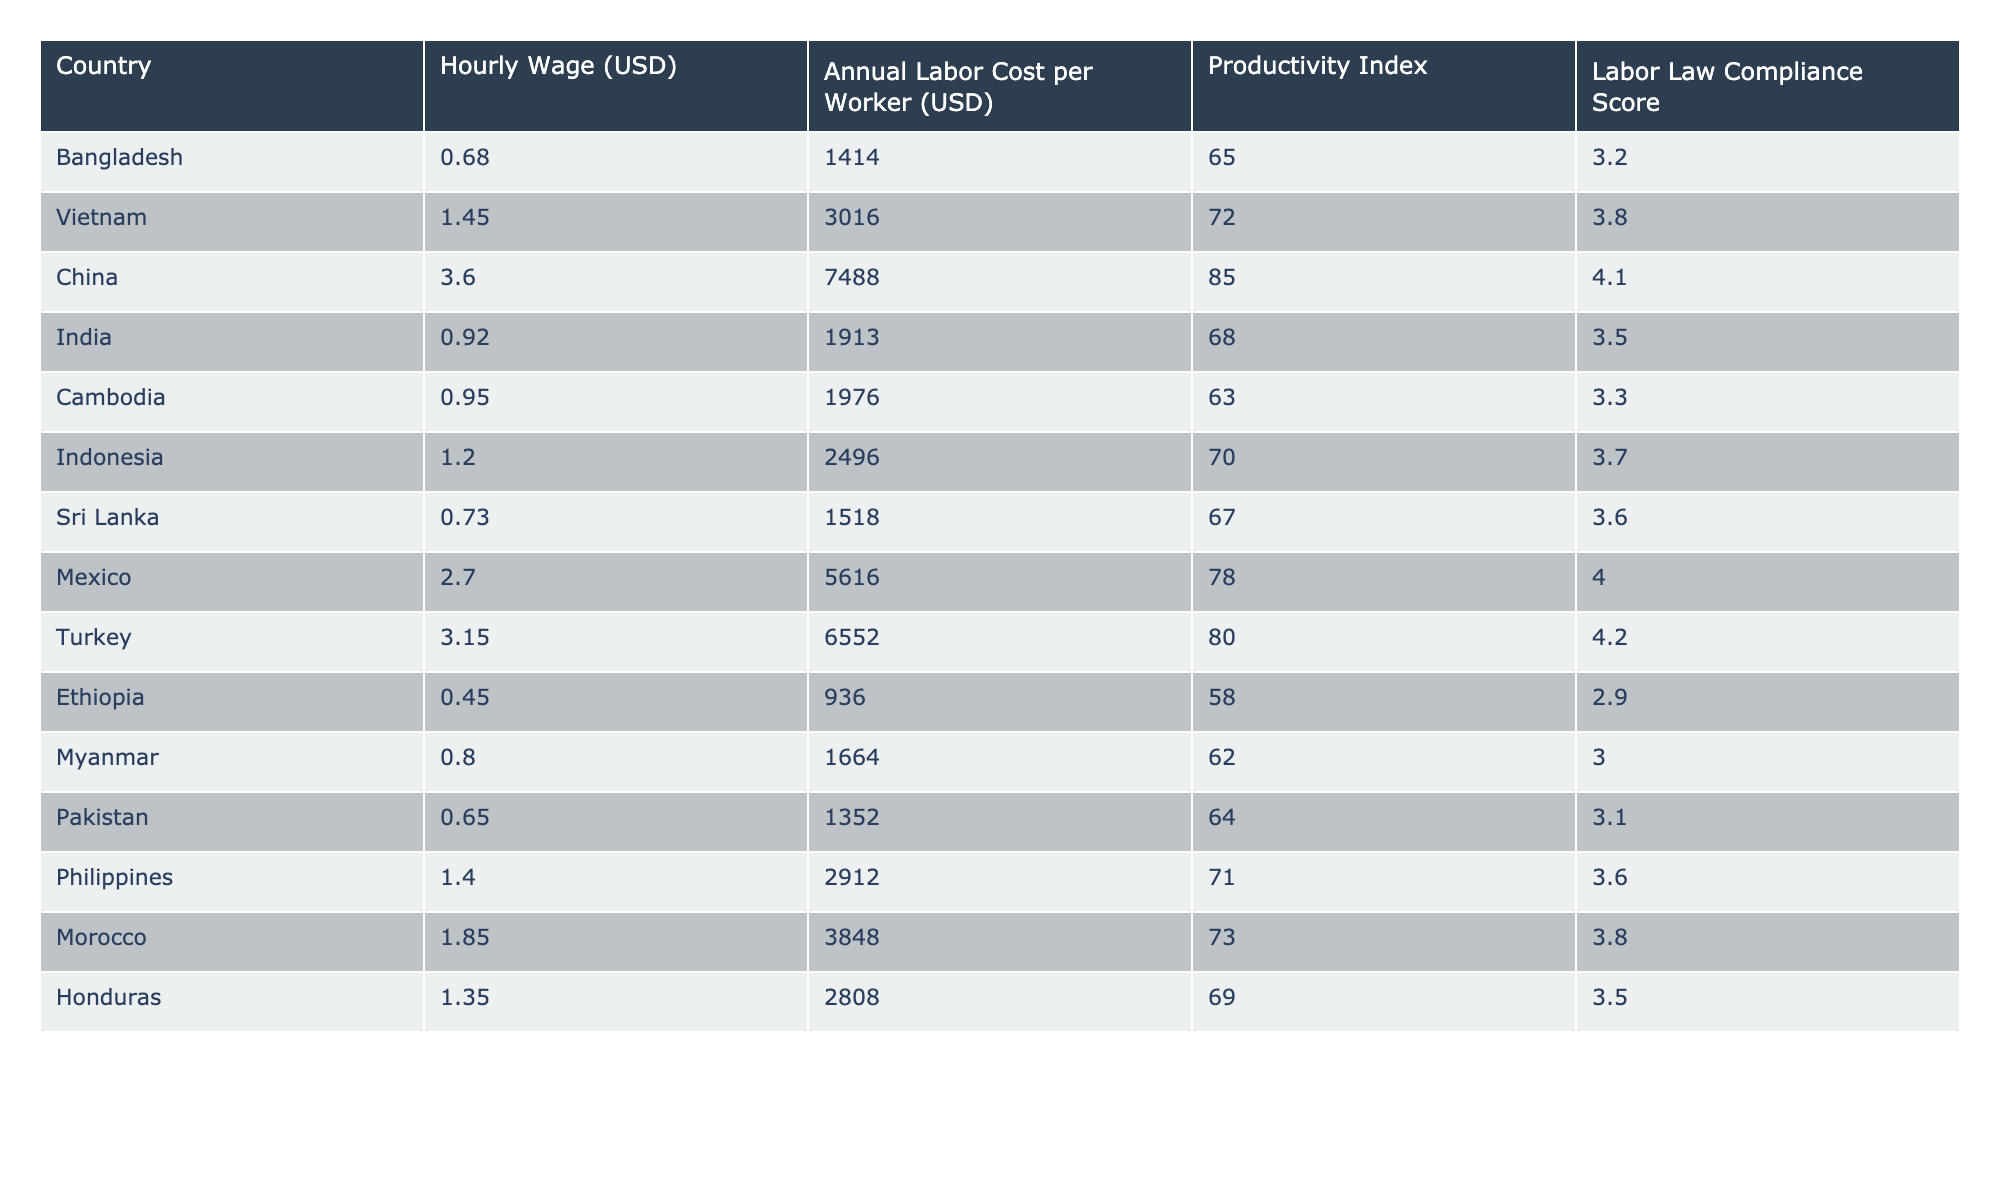What is the hourly wage in Bangladesh? The table indicates that the hourly wage in Bangladesh is listed directly under the "Hourly Wage (USD)" column. The entry shows 0.68.
Answer: 0.68 Which country has the highest annual labor cost per worker? By reviewing the "Annual Labor Cost per Worker (USD)" column, China has the highest value at 7488.
Answer: China What is the productivity index of Vietnam? The productivity index is found under the "Productivity Index" column, and Vietnam's entry shows a value of 72.
Answer: 72 Which country has the lowest labor law compliance score? Referring to the "Labor Law Compliance Score" column, Ethiopia has the lowest score at 2.9.
Answer: Ethiopia What is the difference in annual labor cost between China and India? The annual labor costs for China and India are 7488 and 1913 respectively. The difference is calculated as 7488 - 1913 = 5575.
Answer: 5575 What is the average hourly wage of the countries listed in the table? To find the average, sum all hourly wages (0.68 + 1.45 + 3.60 + 0.92 + 0.95 + 1.20 + 0.73 + 2.70 + 3.15 + 0.45 + 0.80 + 0.65 + 1.40 + 1.85 + 1.35) giving a total of 20.68. Dividing by the number of countries (15) results in an average of 20.68 / 15 = 1.378.
Answer: 1.378 Is the annual labor cost per worker in Pakistan lower than that in Sri Lanka? The annual labor cost for Pakistan is 1352 and for Sri Lanka is 1518. Since 1352 is less than 1518, the answer is yes.
Answer: Yes Which country has a higher productivity index, Indonesia or Cambodia? The productivity index for Indonesia is 70 and for Cambodia is 63. Since 70 > 63, Indonesia has a higher productivity index.
Answer: Indonesia What is the combined annual labor cost of the three highest-cost countries? The three highest-cost countries are China (7488), Turkey (6552), and Mexico (5616). Their combined cost is 7488 + 6552 + 5616 = 19656.
Answer: 19656 Which countries have an hourly wage greater than 1.00? By checking the "Hourly Wage (USD)" column, the countries with an hourly wage greater than 1.00 are Vietnam (1.45), China (3.60), Indonesia (1.20), Mexico (2.70), Turkey (3.15), Morocco (1.85), Philippines (1.40), and Honduras (1.35).
Answer: Vietnam, China, Indonesia, Mexico, Turkey, Morocco, Philippines, Honduras If a country improves its labor law compliance score by 1 point, which country's score would equal Cambodia's compliance score of 3.3? The current score for Ethiopia is 2.9. By adding 1 point to 2.9, it becomes 3.9. However, no score from the other countries matches 3.3. Therefore, none of the countries would equal that score with a +1 point improvement.
Answer: None 